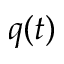<formula> <loc_0><loc_0><loc_500><loc_500>q ( t )</formula> 